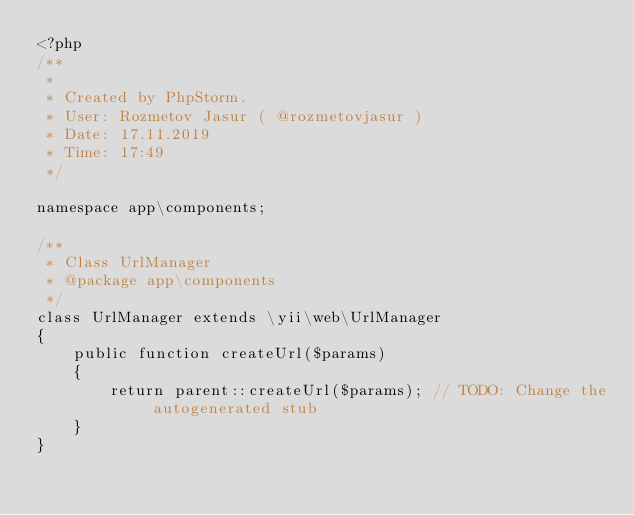<code> <loc_0><loc_0><loc_500><loc_500><_PHP_><?php
/**
 *
 * Created by PhpStorm.
 * User: Rozmetov Jasur ( @rozmetovjasur )
 * Date: 17.11.2019
 * Time: 17:49
 */

namespace app\components;

/**
 * Class UrlManager
 * @package app\components
 */
class UrlManager extends \yii\web\UrlManager
{
    public function createUrl($params)
    {
        return parent::createUrl($params); // TODO: Change the autogenerated stub
    }
}</code> 